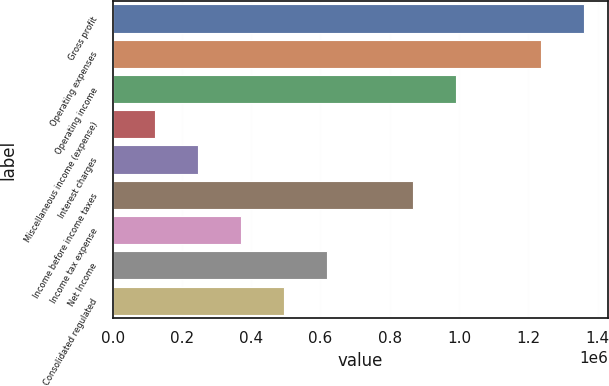Convert chart. <chart><loc_0><loc_0><loc_500><loc_500><bar_chart><fcel>Gross profit<fcel>Operating expenses<fcel>Operating income<fcel>Miscellaneous income (expense)<fcel>Interest charges<fcel>Income before income taxes<fcel>Income tax expense<fcel>Net Income<fcel>Consolidated regulated<nl><fcel>1.36133e+06<fcel>1.23758e+06<fcel>990063<fcel>123762<fcel>247520<fcel>866305<fcel>371277<fcel>618791<fcel>495034<nl></chart> 